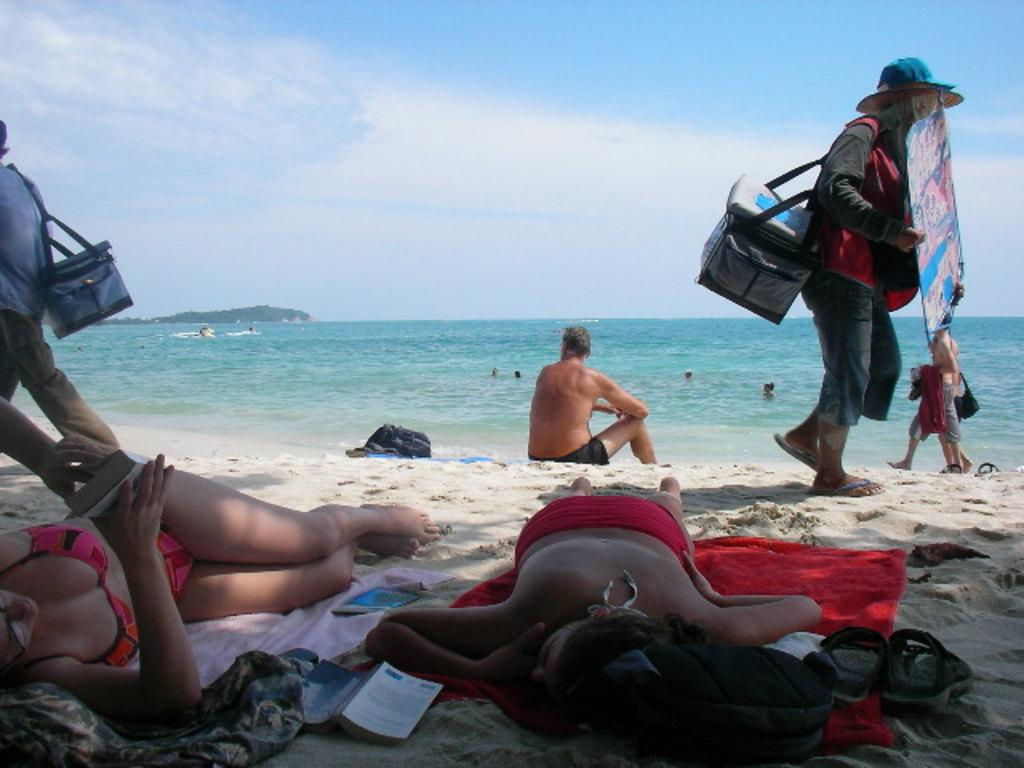What are the two women doing in the image? The two women are laying on the sand in the image. What type of location is depicted in the image? The image shows a beach, as indicated by the presence of sand and an ocean in the background. Can you describe the background of the image? The background of the image includes an ocean and the sky. Are there any other people visible in the image? Yes, there are people on the beach in the image. How are the women using the sand in the image? The women are not actively using the sand in the image; they are simply laying on it. Can you describe the grip of the ocean on the sand in the image? The ocean is not depicted as having a grip on the sand in the image; it is simply a body of water in the background. 